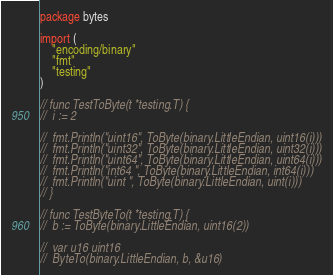<code> <loc_0><loc_0><loc_500><loc_500><_Go_>package bytes

import (
	"encoding/binary"
	"fmt"
	"testing"
)

// func TestToByte(t *testing.T) {
// 	i := 2

// 	fmt.Println("uint16", ToByte(binary.LittleEndian, uint16(i)))
// 	fmt.Println("uint32", ToByte(binary.LittleEndian, uint32(i)))
// 	fmt.Println("uint64", ToByte(binary.LittleEndian, uint64(i)))
// 	fmt.Println("int64 ", ToByte(binary.LittleEndian, int64(i)))
// 	fmt.Println("uint ", ToByte(binary.LittleEndian, uint(i)))
// }

// func TestByteTo(t *testing.T) {
// 	b := ToByte(binary.LittleEndian, uint16(2))

// 	var u16 uint16
// 	ByteTo(binary.LittleEndian, b, &u16)</code> 